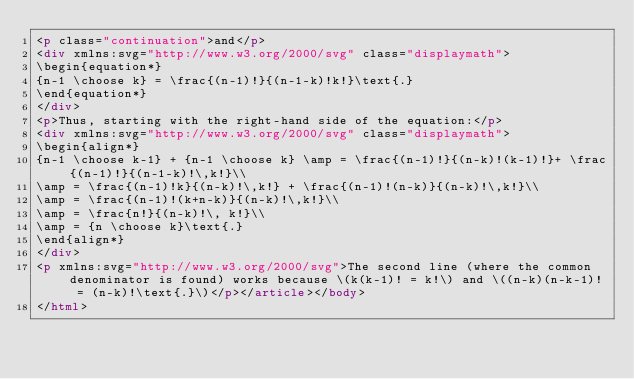<code> <loc_0><loc_0><loc_500><loc_500><_HTML_><p class="continuation">and</p>
<div xmlns:svg="http://www.w3.org/2000/svg" class="displaymath">
\begin{equation*}
{n-1 \choose k} = \frac{(n-1)!}{(n-1-k)!k!}\text{.}
\end{equation*}
</div>
<p>Thus, starting with the right-hand side of the equation:</p>
<div xmlns:svg="http://www.w3.org/2000/svg" class="displaymath">
\begin{align*}
{n-1 \choose k-1} + {n-1 \choose k} \amp = \frac{(n-1)!}{(n-k)!(k-1)!}+ \frac{(n-1)!}{(n-1-k)!\,k!}\\
\amp = \frac{(n-1)!k}{(n-k)!\,k!} + \frac{(n-1)!(n-k)}{(n-k)!\,k!}\\
\amp = \frac{(n-1)!(k+n-k)}{(n-k)!\,k!}\\
\amp = \frac{n!}{(n-k)!\, k!}\\
\amp = {n \choose k}\text{.}
\end{align*}
</div>
<p xmlns:svg="http://www.w3.org/2000/svg">The second line (where the common denominator is found) works because \(k(k-1)! = k!\) and \((n-k)(n-k-1)! = (n-k)!\text{.}\)</p></article></body>
</html>
</code> 